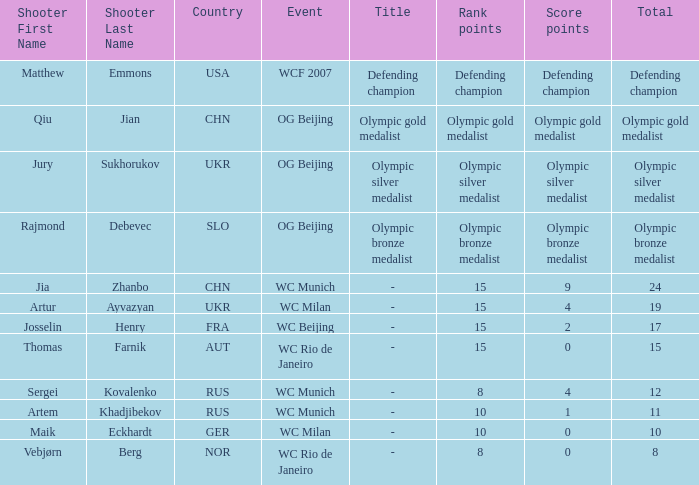With a total of 11, and 10 rank points, what are the score points? 1.0. 